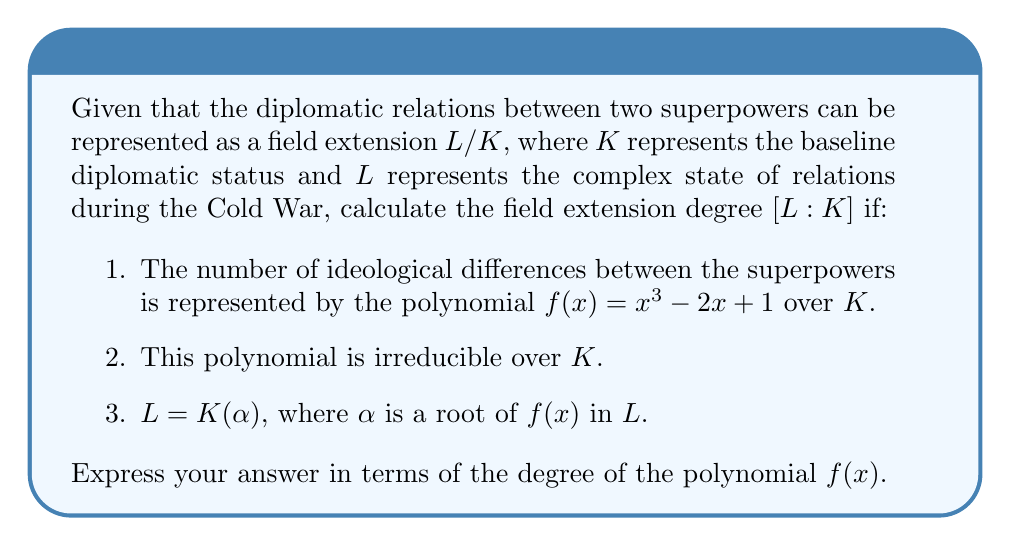Solve this math problem. To solve this problem, we'll follow these steps:

1) First, recall that for a field extension $L/K$ where $L = K(\alpha)$ and $\alpha$ is the root of an irreducible polynomial $f(x)$ over $K$, the degree of the field extension $[L:K]$ is equal to the degree of the polynomial $f(x)$.

2) In this case, we're given that $f(x) = x^3 - 2x + 1$ is irreducible over $K$.

3) The degree of a polynomial is the highest power of $x$ in the polynomial. For $f(x) = x^3 - 2x + 1$, the highest power of $x$ is 3.

4) Therefore, the degree of $f(x)$ is 3.

5) Since $L = K(\alpha)$ where $\alpha$ is a root of $f(x)$, and $f(x)$ is irreducible over $K$, we can conclude that:

   $[L:K] = \text{deg}(f(x)) = 3$

This result suggests that the complexity of diplomatic relations (represented by the field extension degree) is directly related to the degree of the polynomial representing ideological differences, which aligns with the persona's view on the importance of ideological differences in the Cold War.
Answer: $[L:K] = 3$ 